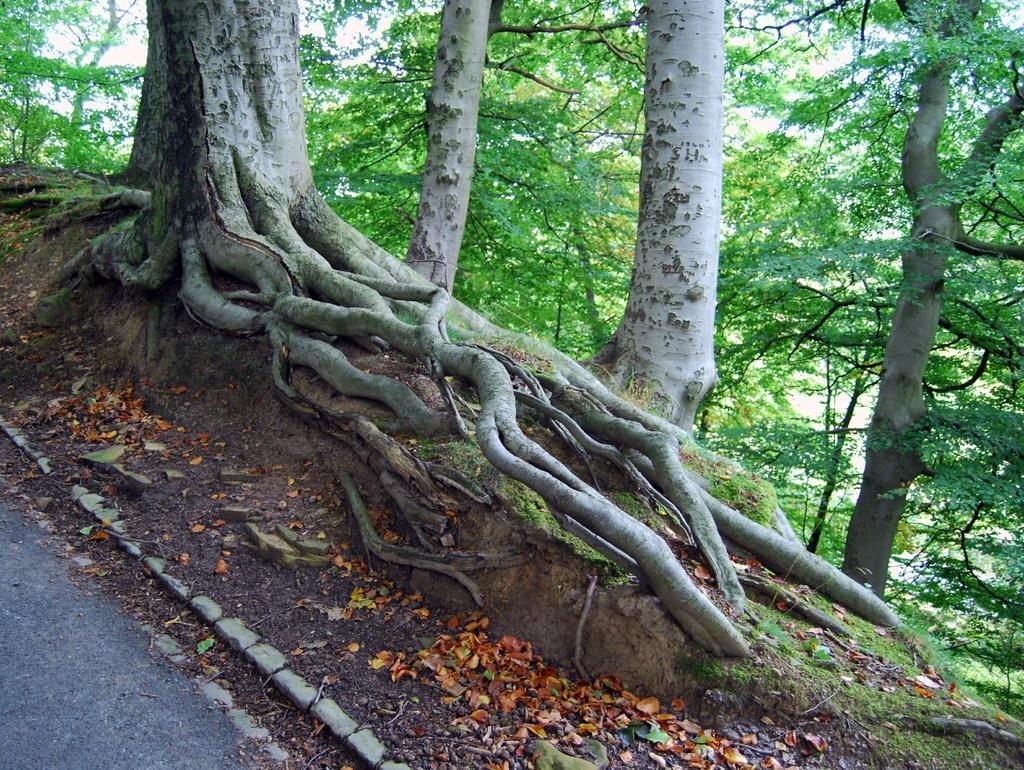In one or two sentences, can you explain what this image depicts? In the image there are many trees on the side of the road. 